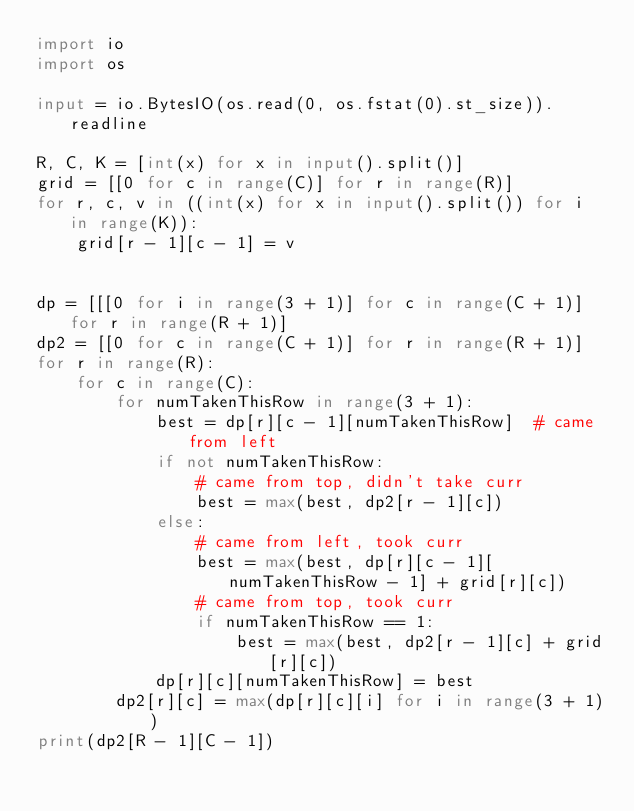Convert code to text. <code><loc_0><loc_0><loc_500><loc_500><_Python_>import io
import os

input = io.BytesIO(os.read(0, os.fstat(0).st_size)).readline

R, C, K = [int(x) for x in input().split()]
grid = [[0 for c in range(C)] for r in range(R)]
for r, c, v in ((int(x) for x in input().split()) for i in range(K)):
    grid[r - 1][c - 1] = v


dp = [[[0 for i in range(3 + 1)] for c in range(C + 1)] for r in range(R + 1)]
dp2 = [[0 for c in range(C + 1)] for r in range(R + 1)]
for r in range(R):
    for c in range(C):
        for numTakenThisRow in range(3 + 1):
            best = dp[r][c - 1][numTakenThisRow]  # came from left
            if not numTakenThisRow:
                # came from top, didn't take curr
                best = max(best, dp2[r - 1][c])
            else:
                # came from left, took curr
                best = max(best, dp[r][c - 1][numTakenThisRow - 1] + grid[r][c])
                # came from top, took curr
                if numTakenThisRow == 1:
                    best = max(best, dp2[r - 1][c] + grid[r][c])
            dp[r][c][numTakenThisRow] = best
        dp2[r][c] = max(dp[r][c][i] for i in range(3 + 1))
print(dp2[R - 1][C - 1])
</code> 